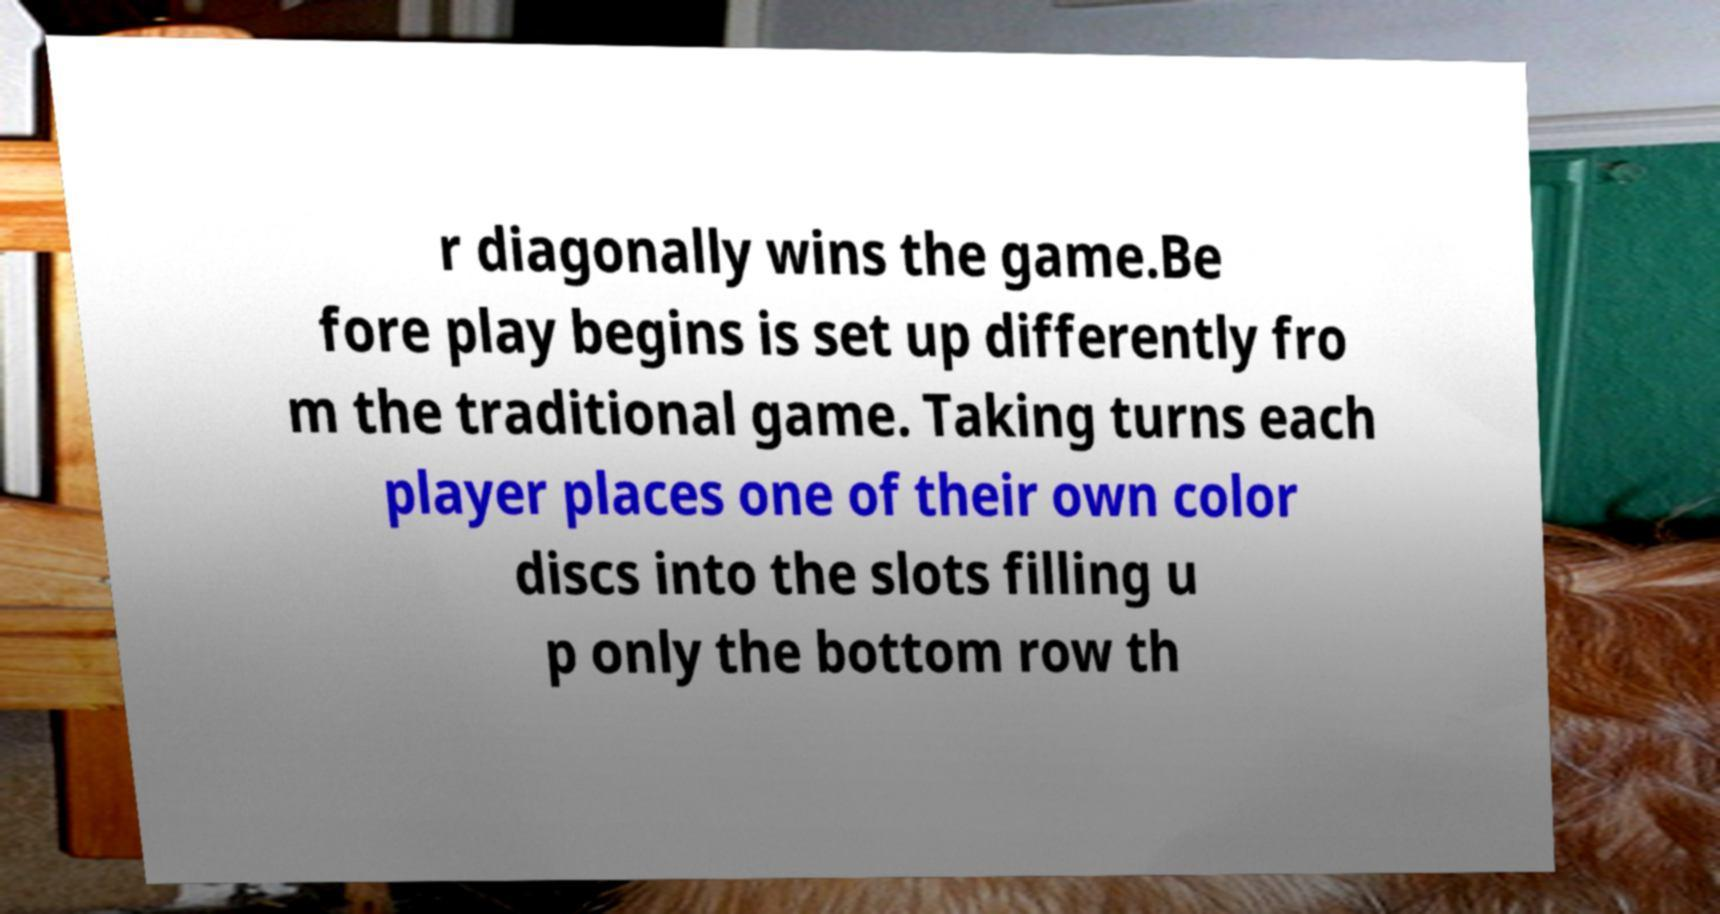I need the written content from this picture converted into text. Can you do that? r diagonally wins the game.Be fore play begins is set up differently fro m the traditional game. Taking turns each player places one of their own color discs into the slots filling u p only the bottom row th 